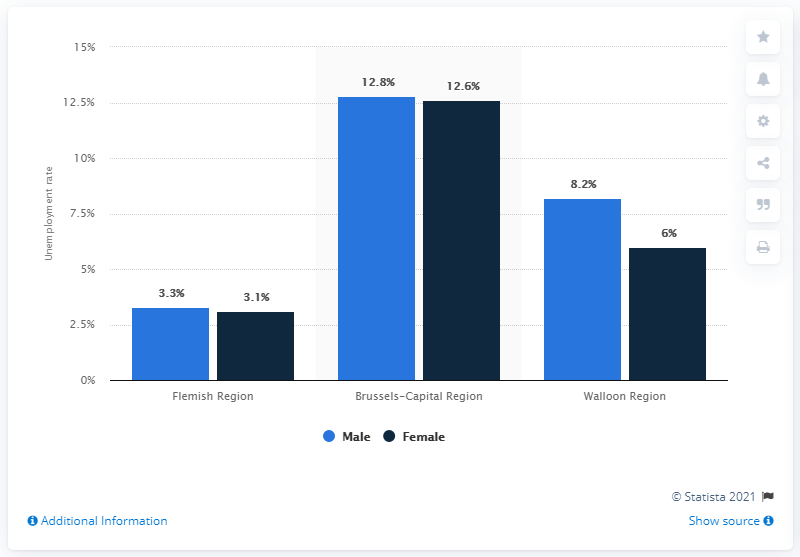List a handful of essential elements in this visual. In 2019, the male unemployment rate in the Brussels-Capital Region was 12.8%. In 2019, the female unemployment rate in the Brussels-Capital Region was 12.6%. 